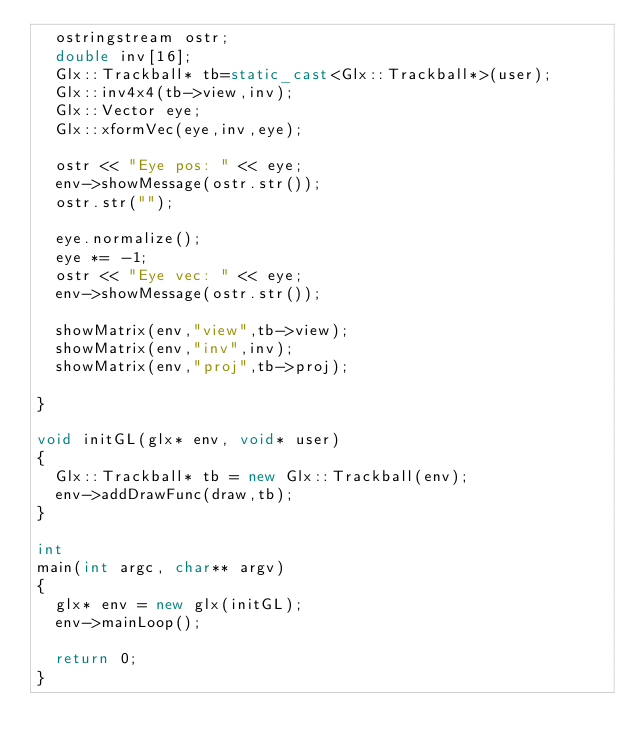<code> <loc_0><loc_0><loc_500><loc_500><_C++_>  ostringstream ostr;
  double inv[16];
  Glx::Trackball* tb=static_cast<Glx::Trackball*>(user);
  Glx::inv4x4(tb->view,inv);
  Glx::Vector eye;
  Glx::xformVec(eye,inv,eye);
  
  ostr << "Eye pos: " << eye;
  env->showMessage(ostr.str());
  ostr.str("");  

  eye.normalize();
  eye *= -1;
  ostr << "Eye vec: " << eye;
  env->showMessage(ostr.str());

  showMatrix(env,"view",tb->view);
  showMatrix(env,"inv",inv);
  showMatrix(env,"proj",tb->proj);

}

void initGL(glx* env, void* user)
{
  Glx::Trackball* tb = new Glx::Trackball(env);
  env->addDrawFunc(draw,tb);
}

int
main(int argc, char** argv)
{
  glx* env = new glx(initGL);
  env->mainLoop();

  return 0;
}
</code> 